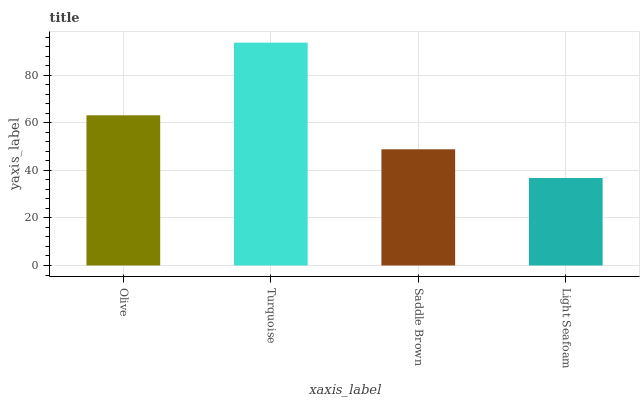Is Light Seafoam the minimum?
Answer yes or no. Yes. Is Turquoise the maximum?
Answer yes or no. Yes. Is Saddle Brown the minimum?
Answer yes or no. No. Is Saddle Brown the maximum?
Answer yes or no. No. Is Turquoise greater than Saddle Brown?
Answer yes or no. Yes. Is Saddle Brown less than Turquoise?
Answer yes or no. Yes. Is Saddle Brown greater than Turquoise?
Answer yes or no. No. Is Turquoise less than Saddle Brown?
Answer yes or no. No. Is Olive the high median?
Answer yes or no. Yes. Is Saddle Brown the low median?
Answer yes or no. Yes. Is Light Seafoam the high median?
Answer yes or no. No. Is Turquoise the low median?
Answer yes or no. No. 